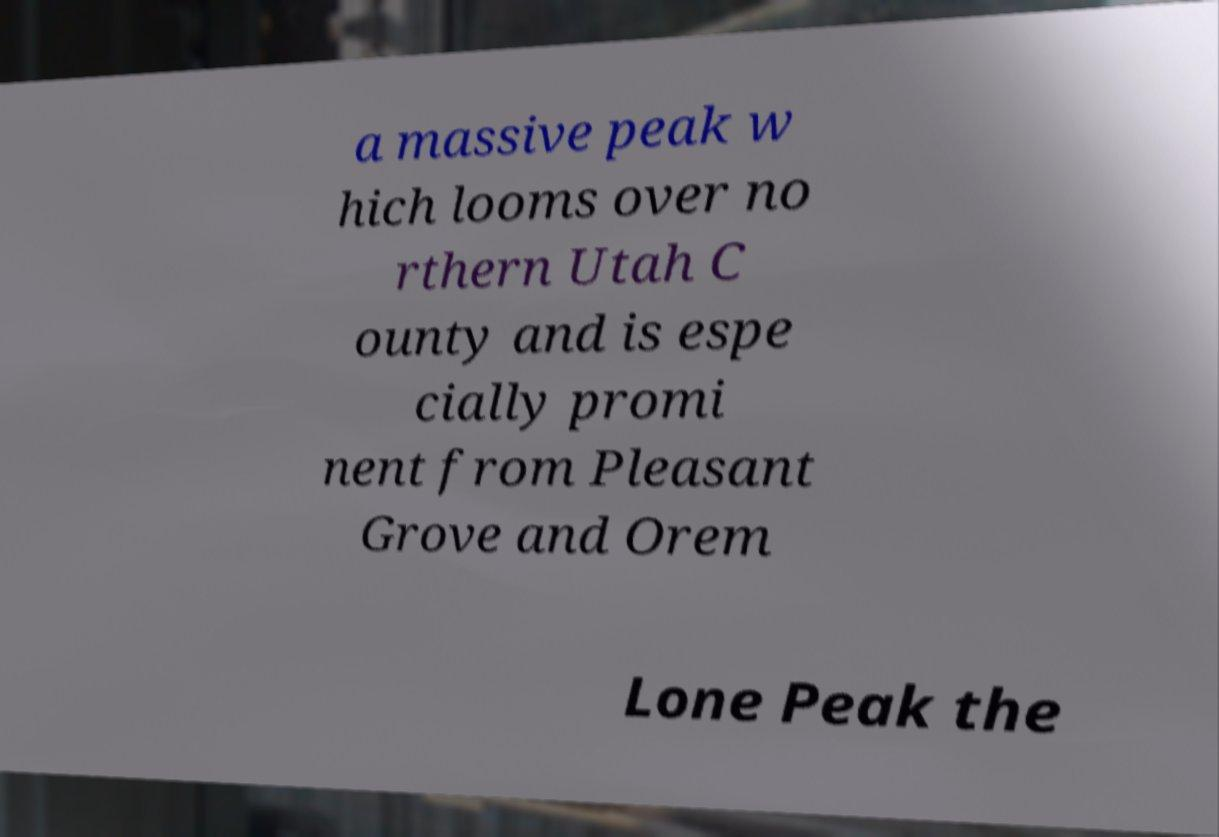For documentation purposes, I need the text within this image transcribed. Could you provide that? a massive peak w hich looms over no rthern Utah C ounty and is espe cially promi nent from Pleasant Grove and Orem Lone Peak the 